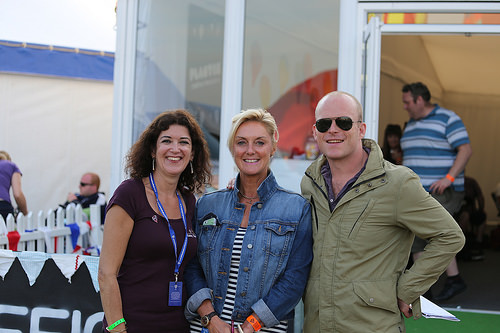<image>
Is the man in front of the woman? No. The man is not in front of the woman. The spatial positioning shows a different relationship between these objects. Where is the woman in relation to the man? Is it in front of the man? No. The woman is not in front of the man. The spatial positioning shows a different relationship between these objects. 